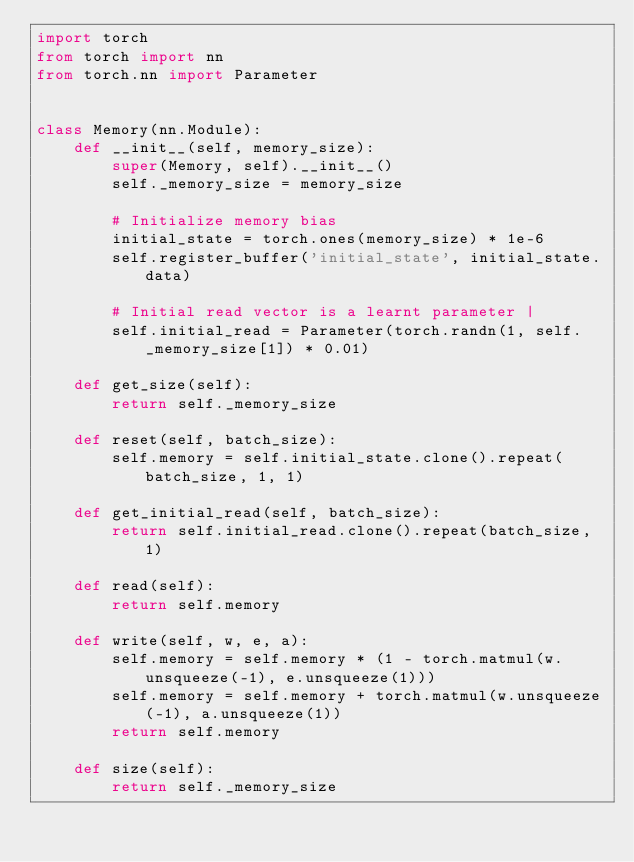Convert code to text. <code><loc_0><loc_0><loc_500><loc_500><_Python_>import torch
from torch import nn
from torch.nn import Parameter


class Memory(nn.Module):
    def __init__(self, memory_size):
        super(Memory, self).__init__()
        self._memory_size = memory_size

        # Initialize memory bias
        initial_state = torch.ones(memory_size) * 1e-6
        self.register_buffer('initial_state', initial_state.data)

        # Initial read vector is a learnt parameter |         
        self.initial_read = Parameter(torch.randn(1, self._memory_size[1]) * 0.01)

    def get_size(self):
        return self._memory_size

    def reset(self, batch_size):
        self.memory = self.initial_state.clone().repeat(batch_size, 1, 1)

    def get_initial_read(self, batch_size):
        return self.initial_read.clone().repeat(batch_size, 1)

    def read(self):
        return self.memory

    def write(self, w, e, a):
        self.memory = self.memory * (1 - torch.matmul(w.unsqueeze(-1), e.unsqueeze(1)))
        self.memory = self.memory + torch.matmul(w.unsqueeze(-1), a.unsqueeze(1))
        return self.memory

    def size(self):
        return self._memory_size
</code> 